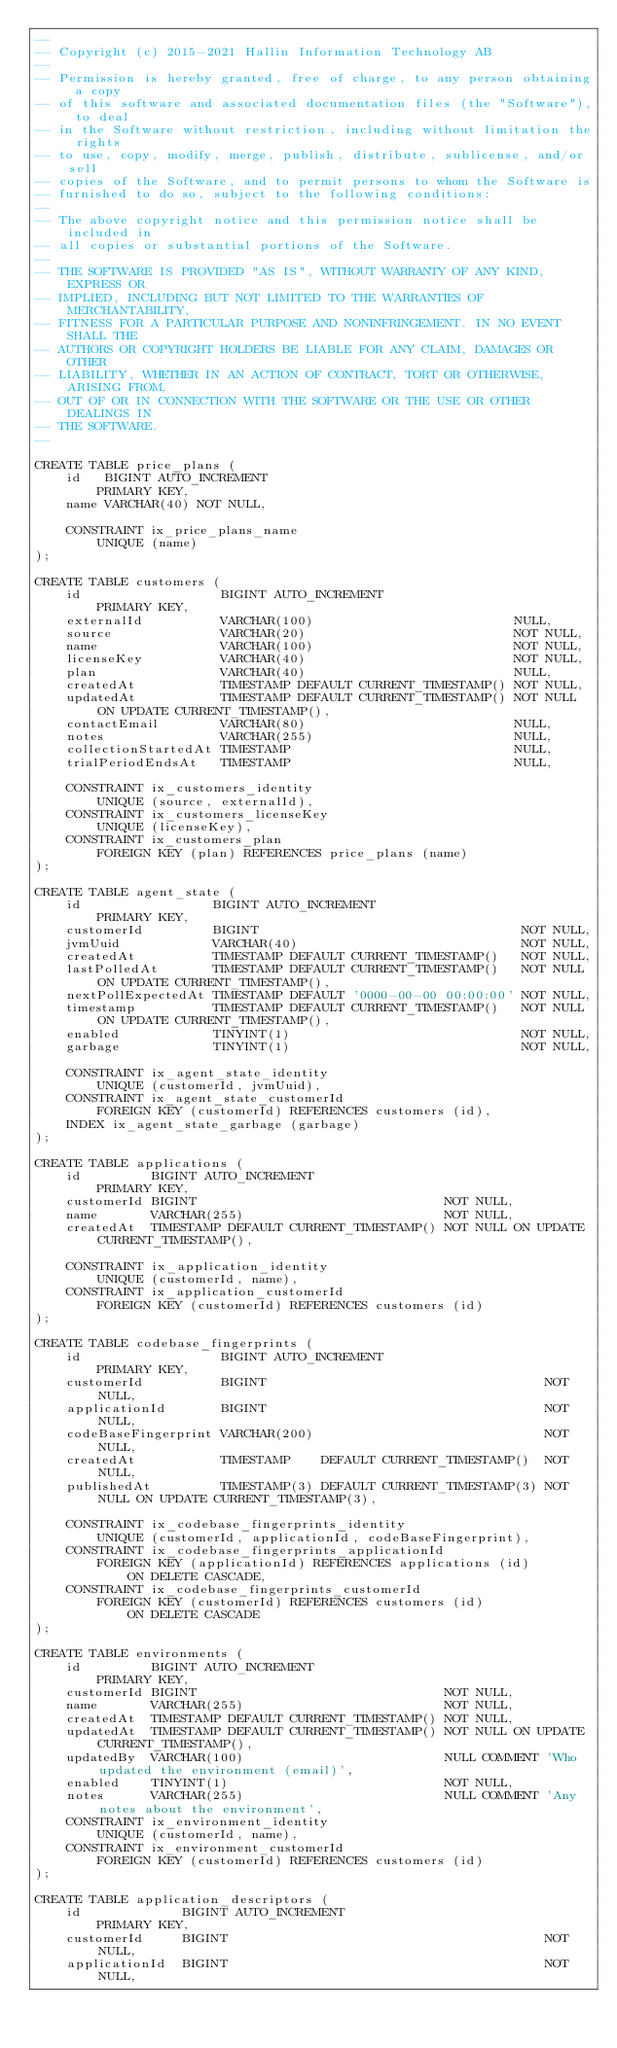Convert code to text. <code><loc_0><loc_0><loc_500><loc_500><_SQL_>--
-- Copyright (c) 2015-2021 Hallin Information Technology AB
--
-- Permission is hereby granted, free of charge, to any person obtaining a copy
-- of this software and associated documentation files (the "Software"), to deal
-- in the Software without restriction, including without limitation the rights
-- to use, copy, modify, merge, publish, distribute, sublicense, and/or sell
-- copies of the Software, and to permit persons to whom the Software is
-- furnished to do so, subject to the following conditions:
--
-- The above copyright notice and this permission notice shall be included in
-- all copies or substantial portions of the Software.
--
-- THE SOFTWARE IS PROVIDED "AS IS", WITHOUT WARRANTY OF ANY KIND, EXPRESS OR
-- IMPLIED, INCLUDING BUT NOT LIMITED TO THE WARRANTIES OF MERCHANTABILITY,
-- FITNESS FOR A PARTICULAR PURPOSE AND NONINFRINGEMENT. IN NO EVENT SHALL THE
-- AUTHORS OR COPYRIGHT HOLDERS BE LIABLE FOR ANY CLAIM, DAMAGES OR OTHER
-- LIABILITY, WHETHER IN AN ACTION OF CONTRACT, TORT OR OTHERWISE, ARISING FROM,
-- OUT OF OR IN CONNECTION WITH THE SOFTWARE OR THE USE OR OTHER DEALINGS IN
-- THE SOFTWARE.
--

CREATE TABLE price_plans (
    id   BIGINT AUTO_INCREMENT
        PRIMARY KEY,
    name VARCHAR(40) NOT NULL,

    CONSTRAINT ix_price_plans_name
        UNIQUE (name)
);

CREATE TABLE customers (
    id                  BIGINT AUTO_INCREMENT
        PRIMARY KEY,
    externalId          VARCHAR(100)                          NULL,
    source              VARCHAR(20)                           NOT NULL,
    name                VARCHAR(100)                          NOT NULL,
    licenseKey          VARCHAR(40)                           NOT NULL,
    plan                VARCHAR(40)                           NULL,
    createdAt           TIMESTAMP DEFAULT CURRENT_TIMESTAMP() NOT NULL,
    updatedAt           TIMESTAMP DEFAULT CURRENT_TIMESTAMP() NOT NULL ON UPDATE CURRENT_TIMESTAMP(),
    contactEmail        VARCHAR(80)                           NULL,
    notes               VARCHAR(255)                          NULL,
    collectionStartedAt TIMESTAMP                             NULL,
    trialPeriodEndsAt   TIMESTAMP                             NULL,

    CONSTRAINT ix_customers_identity
        UNIQUE (source, externalId),
    CONSTRAINT ix_customers_licenseKey
        UNIQUE (licenseKey),
    CONSTRAINT ix_customers_plan
        FOREIGN KEY (plan) REFERENCES price_plans (name)
);

CREATE TABLE agent_state (
    id                 BIGINT AUTO_INCREMENT
        PRIMARY KEY,
    customerId         BIGINT                                  NOT NULL,
    jvmUuid            VARCHAR(40)                             NOT NULL,
    createdAt          TIMESTAMP DEFAULT CURRENT_TIMESTAMP()   NOT NULL,
    lastPolledAt       TIMESTAMP DEFAULT CURRENT_TIMESTAMP()   NOT NULL ON UPDATE CURRENT_TIMESTAMP(),
    nextPollExpectedAt TIMESTAMP DEFAULT '0000-00-00 00:00:00' NOT NULL,
    timestamp          TIMESTAMP DEFAULT CURRENT_TIMESTAMP()   NOT NULL ON UPDATE CURRENT_TIMESTAMP(),
    enabled            TINYINT(1)                              NOT NULL,
    garbage            TINYINT(1)                              NOT NULL,

    CONSTRAINT ix_agent_state_identity
        UNIQUE (customerId, jvmUuid),
    CONSTRAINT ix_agent_state_customerId
        FOREIGN KEY (customerId) REFERENCES customers (id),
    INDEX ix_agent_state_garbage (garbage)
);

CREATE TABLE applications (
    id         BIGINT AUTO_INCREMENT
        PRIMARY KEY,
    customerId BIGINT                                NOT NULL,
    name       VARCHAR(255)                          NOT NULL,
    createdAt  TIMESTAMP DEFAULT CURRENT_TIMESTAMP() NOT NULL ON UPDATE CURRENT_TIMESTAMP(),

    CONSTRAINT ix_application_identity
        UNIQUE (customerId, name),
    CONSTRAINT ix_application_customerId
        FOREIGN KEY (customerId) REFERENCES customers (id)
);

CREATE TABLE codebase_fingerprints (
    id                  BIGINT AUTO_INCREMENT
        PRIMARY KEY,
    customerId          BIGINT                                    NOT NULL,
    applicationId       BIGINT                                    NOT NULL,
    codeBaseFingerprint VARCHAR(200)                              NOT NULL,
    createdAt           TIMESTAMP    DEFAULT CURRENT_TIMESTAMP()  NOT NULL,
    publishedAt         TIMESTAMP(3) DEFAULT CURRENT_TIMESTAMP(3) NOT NULL ON UPDATE CURRENT_TIMESTAMP(3),

    CONSTRAINT ix_codebase_fingerprints_identity
        UNIQUE (customerId, applicationId, codeBaseFingerprint),
    CONSTRAINT ix_codebase_fingerprints_applicationId
        FOREIGN KEY (applicationId) REFERENCES applications (id)
            ON DELETE CASCADE,
    CONSTRAINT ix_codebase_fingerprints_customerId
        FOREIGN KEY (customerId) REFERENCES customers (id)
            ON DELETE CASCADE
);

CREATE TABLE environments (
    id         BIGINT AUTO_INCREMENT
        PRIMARY KEY,
    customerId BIGINT                                NOT NULL,
    name       VARCHAR(255)                          NOT NULL,
    createdAt  TIMESTAMP DEFAULT CURRENT_TIMESTAMP() NOT NULL,
    updatedAt  TIMESTAMP DEFAULT CURRENT_TIMESTAMP() NOT NULL ON UPDATE CURRENT_TIMESTAMP(),
    updatedBy  VARCHAR(100)                          NULL COMMENT 'Who updated the environment (email)',
    enabled    TINYINT(1)                            NOT NULL,
    notes      VARCHAR(255)                          NULL COMMENT 'Any notes about the environment',
    CONSTRAINT ix_environment_identity
        UNIQUE (customerId, name),
    CONSTRAINT ix_environment_customerId
        FOREIGN KEY (customerId) REFERENCES customers (id)
);

CREATE TABLE application_descriptors (
    id             BIGINT AUTO_INCREMENT
        PRIMARY KEY,
    customerId     BIGINT                                         NOT NULL,
    applicationId  BIGINT                                         NOT NULL,</code> 